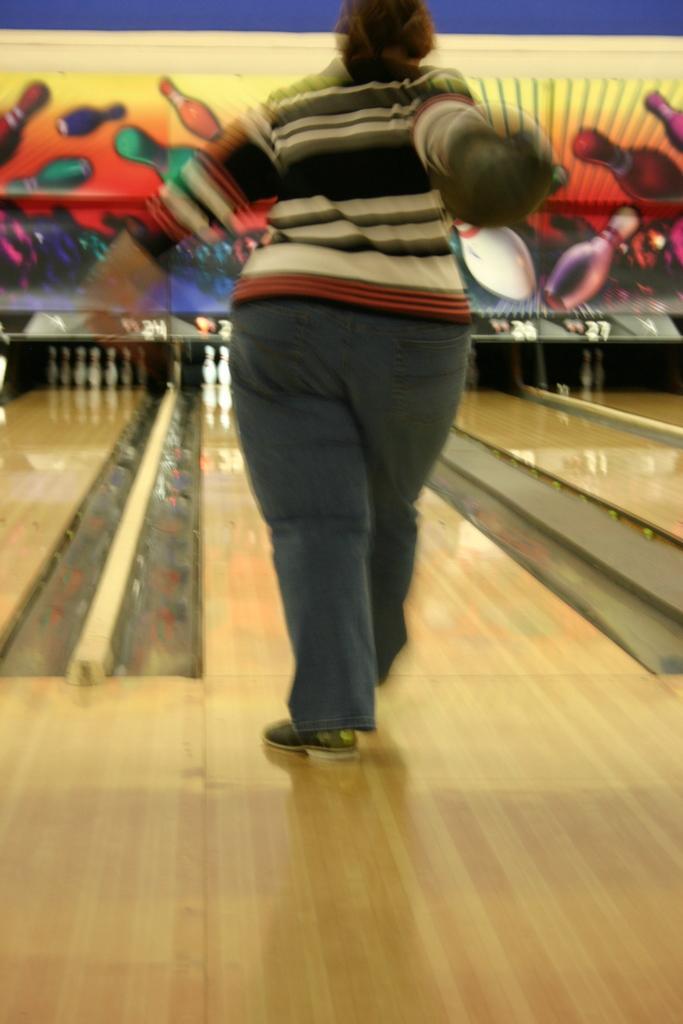Could you give a brief overview of what you see in this image? Here I can see a person holding a ball in hand and standing on the floor facing towards the back side. It seems like this person is playing ten-pin bowling. In the background there is a board. 